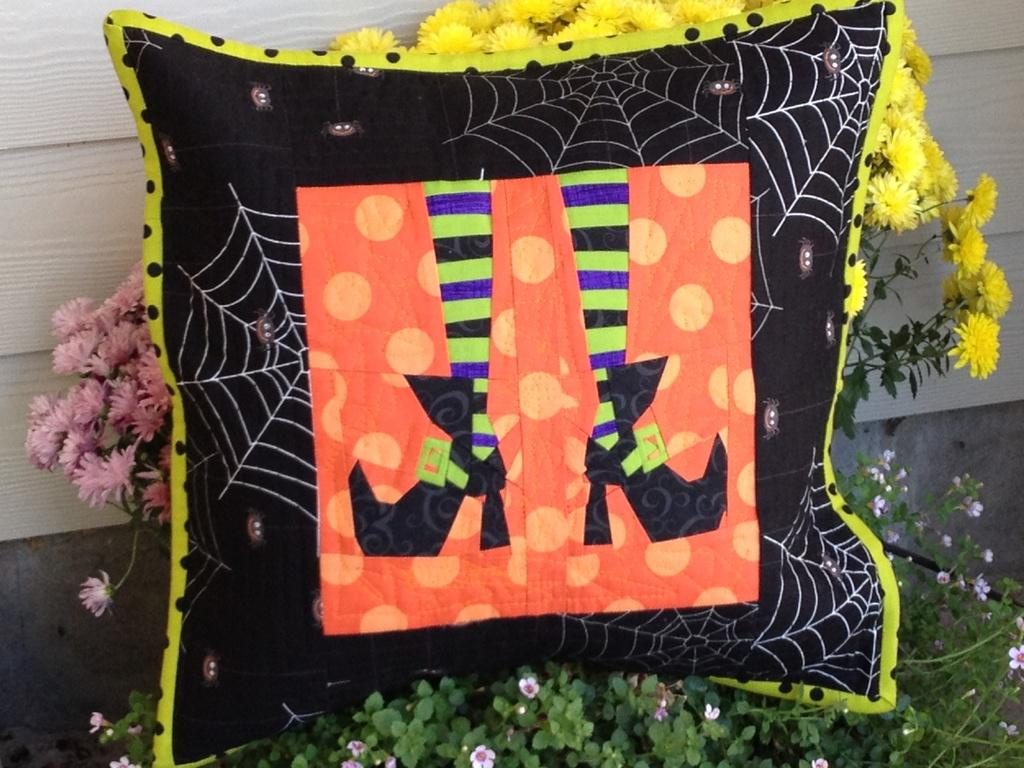What object can be seen in the image that is typically used for comfort? There is a pillow in the image. What type of decorative items are present in the image? There are flowers in the image. What type of living organisms can be seen in the image? There are plants in the image. What type of rod can be seen holding up the flowers in the image? There is no rod present in the image; the flowers are not being held up by any visible support. 